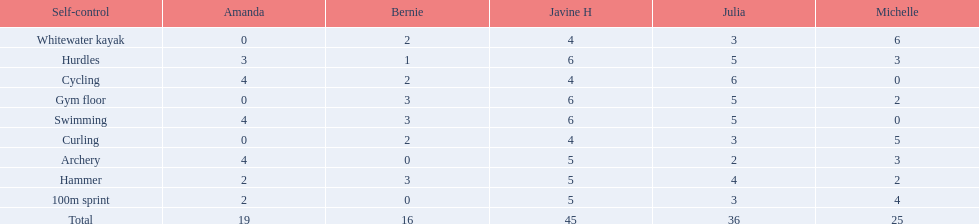What other girl besides amanda also had a 4 in cycling? Javine H. 